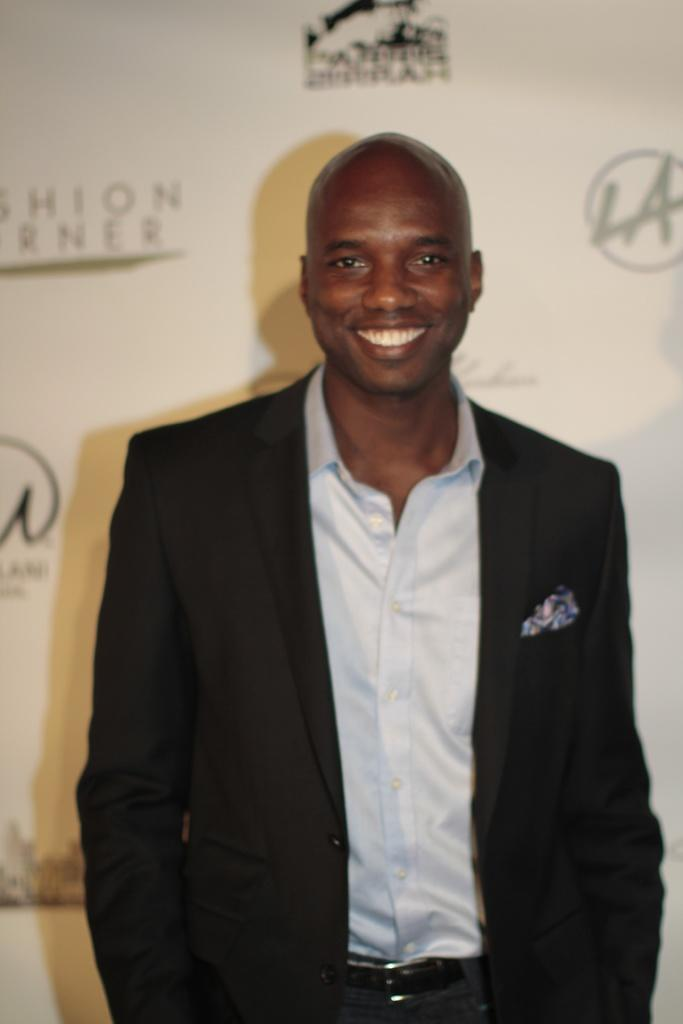What is the main subject of the image? There is a person in the image. What is the person doing in the image? The person is standing and smiling. What can be seen in the background of the image? There is a banner in the background of the image. What is written or displayed on the banner? The banner has sponsor names and logos. What is the person's net worth in the image? There is no information about the person's net worth in the image. What type of lipstick is the person wearing in the image? There is no information about the person's lipstick in the image. 